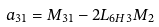Convert formula to latex. <formula><loc_0><loc_0><loc_500><loc_500>a _ { 3 1 } & = M _ { 3 1 } - 2 L _ { 6 H 3 } M _ { 2 }</formula> 